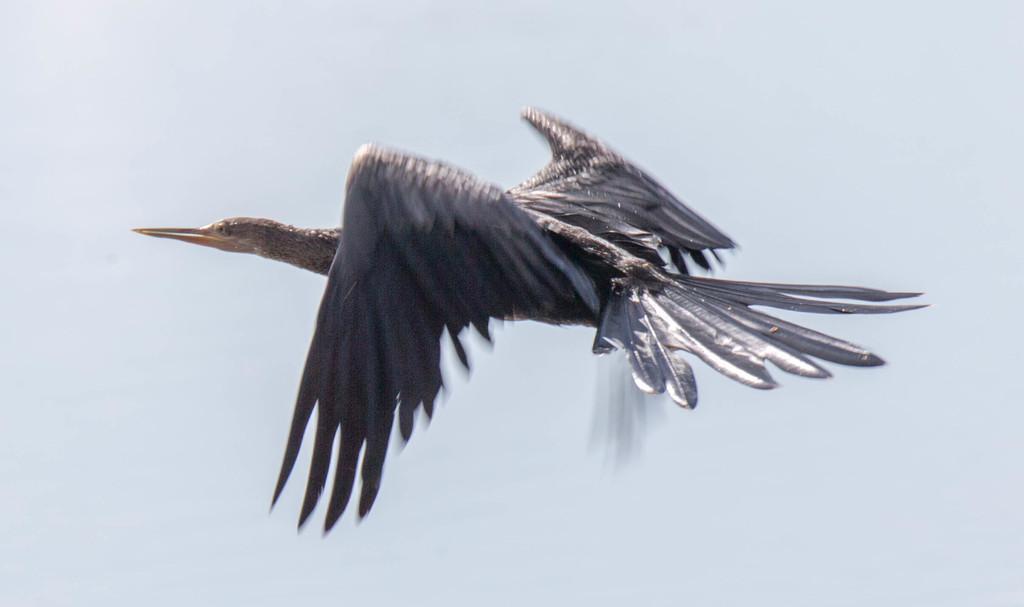Could you give a brief overview of what you see in this image? In the center of the image we can see a bird flying. 